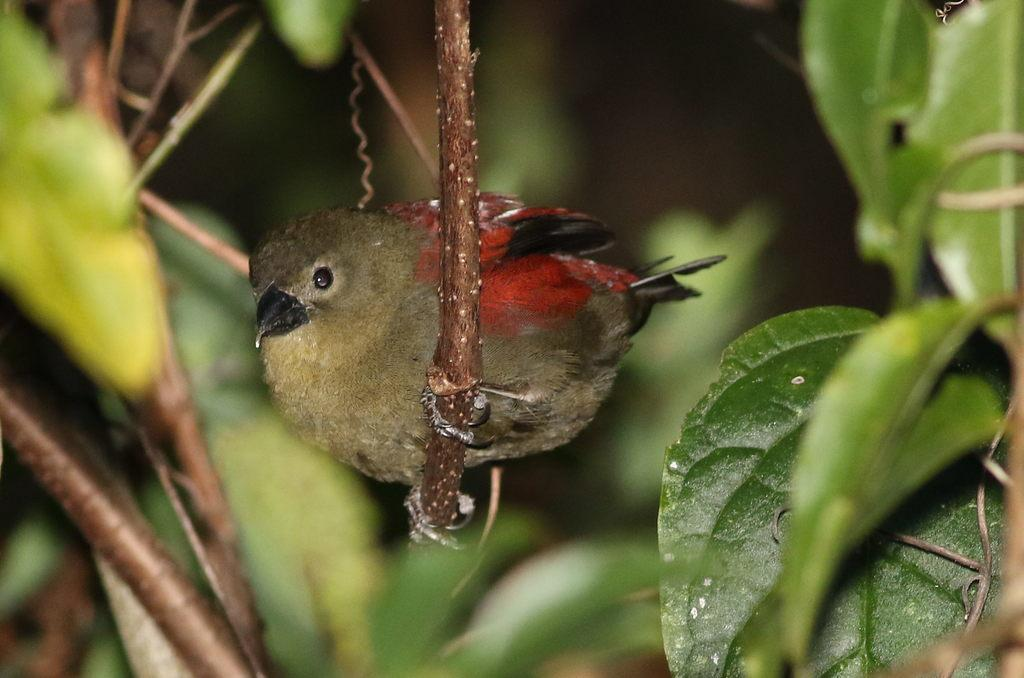What type of animal can be seen in the picture? There is a bird in the picture. What natural elements are present in the image? There are trees in the picture. How would you describe the background of the image? The background of the image is blurry. What type of ornament is hanging from the bird's beak in the image? There is no ornament hanging from the bird's beak in the image; the bird is not depicted with any accessories. 